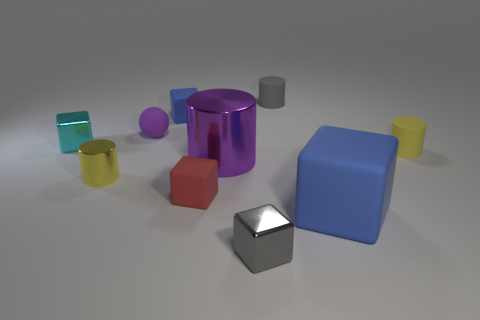How many blue cubes must be subtracted to get 1 blue cubes? 1 Subtract all shiny cubes. How many cubes are left? 3 Subtract all cyan cylinders. How many blue blocks are left? 2 Subtract all purple cylinders. How many cylinders are left? 3 Subtract 1 blocks. How many blocks are left? 4 Add 9 yellow metallic cubes. How many yellow metallic cubes exist? 9 Subtract 0 brown cubes. How many objects are left? 10 Subtract all cylinders. How many objects are left? 6 Subtract all cyan balls. Subtract all gray blocks. How many balls are left? 1 Subtract all small red matte things. Subtract all small cyan things. How many objects are left? 8 